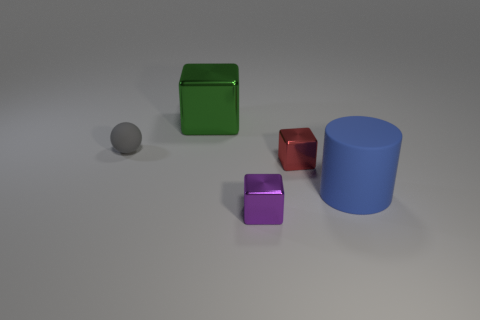Add 2 big rubber things. How many objects exist? 7 Subtract all small purple shiny blocks. How many blocks are left? 2 Subtract all red blocks. How many blocks are left? 2 Subtract 1 balls. How many balls are left? 0 Subtract all yellow spheres. How many red cubes are left? 1 Add 4 blue things. How many blue things exist? 5 Subtract 0 green cylinders. How many objects are left? 5 Subtract all spheres. How many objects are left? 4 Subtract all brown blocks. Subtract all green spheres. How many blocks are left? 3 Subtract all cubes. Subtract all green rubber balls. How many objects are left? 2 